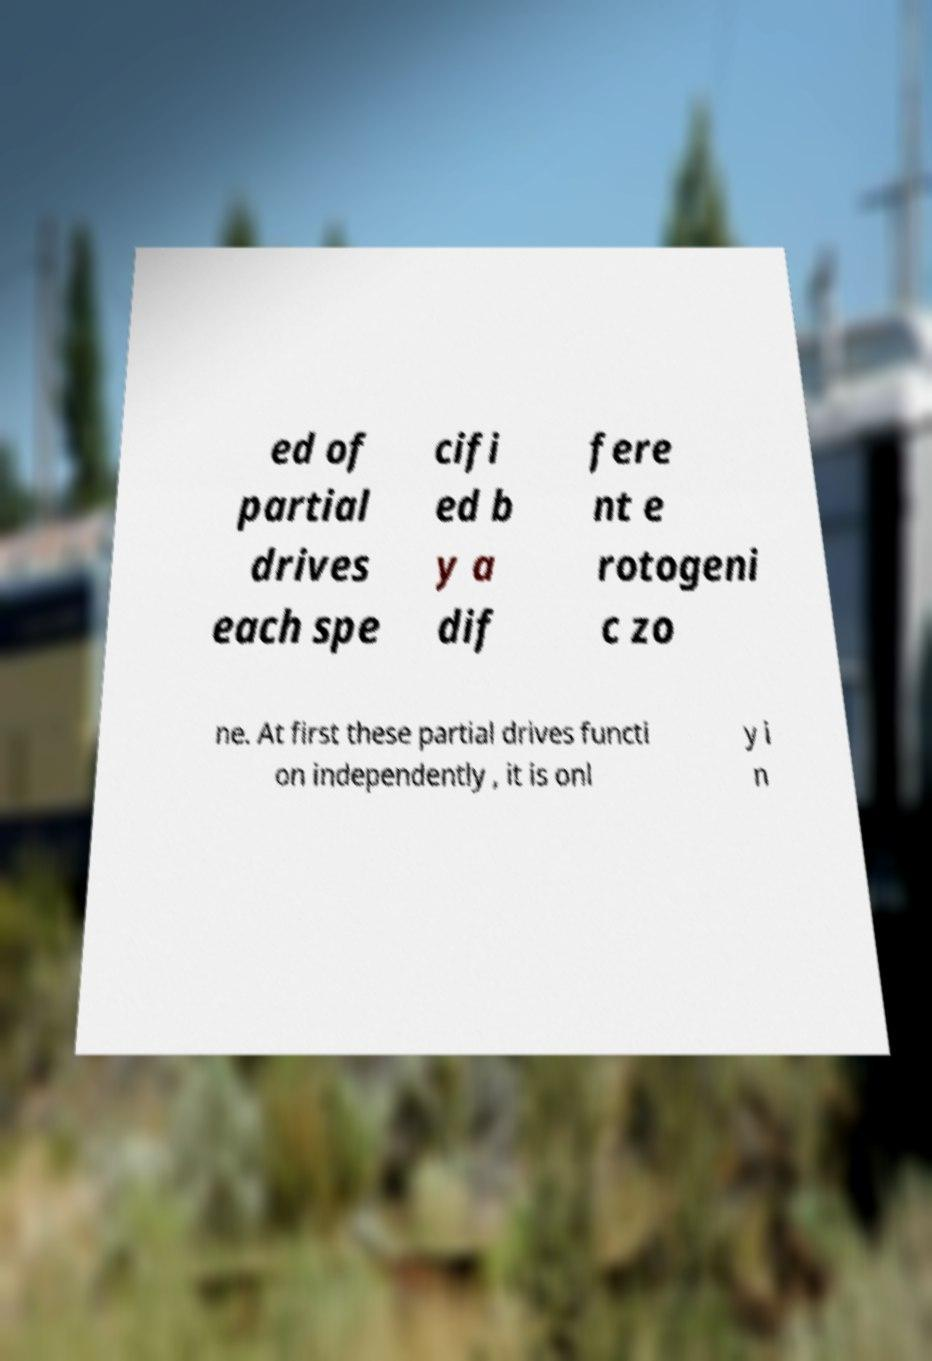Please read and relay the text visible in this image. What does it say? ed of partial drives each spe cifi ed b y a dif fere nt e rotogeni c zo ne. At first these partial drives functi on independently , it is onl y i n 